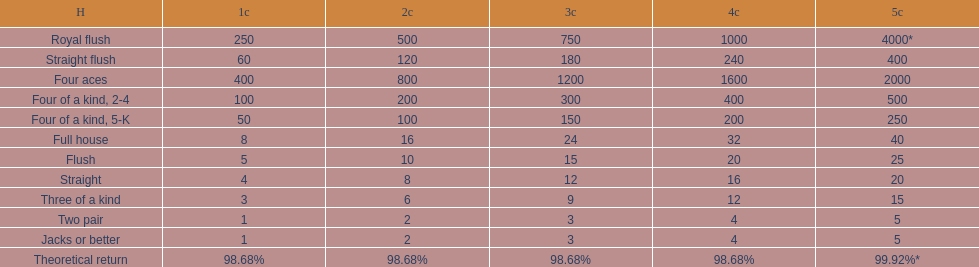Is four 5s worth more or less than four 2s? Less. 